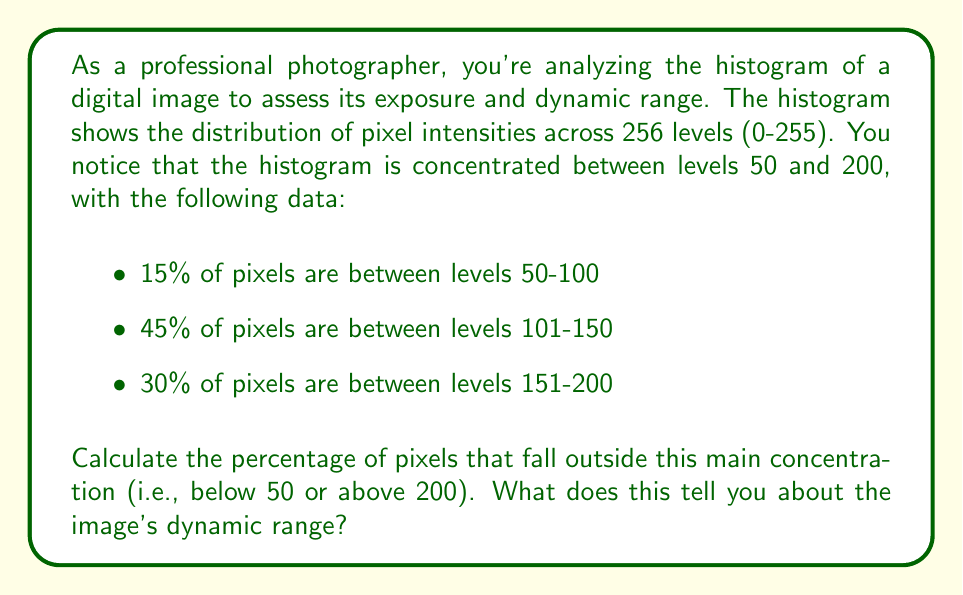Help me with this question. To solve this problem, we need to follow these steps:

1. Calculate the total percentage of pixels in the given ranges:
   $15\% + 45\% + 30\% = 90\%$

2. Determine the percentage of pixels outside this range:
   $100\% - 90\% = 10\%$

3. Interpret the results:
   The fact that 90% of the pixels fall within the range of 50-200 (out of 0-255) indicates that the image has a relatively narrow dynamic range. This means that the image may lack detail in the shadows (below 50) and highlights (above 200).

   The dynamic range of an image can be quantified using the following formula:

   $$ \text{Dynamic Range} = \log_2\left(\frac{\text{Max Intensity}}{\text{Min Intensity}}\right) $$

   In this case, if we consider the main concentration of pixels:

   $$ \text{Dynamic Range} \approx \log_2\left(\frac{200}{50}\right) \approx 2 \text{ stops} $$

   This is relatively low, as many digital cameras can capture a dynamic range of 10-14 stops.

4. Implications for the image:
   - The image may appear flat or lacking in contrast.
   - There might be limited detail in very dark or very bright areas.
   - The image might benefit from post-processing techniques to expand the dynamic range, such as tone mapping or HDR merging.
Answer: 10% of pixels fall outside the main concentration (below 50 or above 200). This indicates a relatively narrow dynamic range of approximately 2 stops, suggesting limited detail in shadows and highlights. 